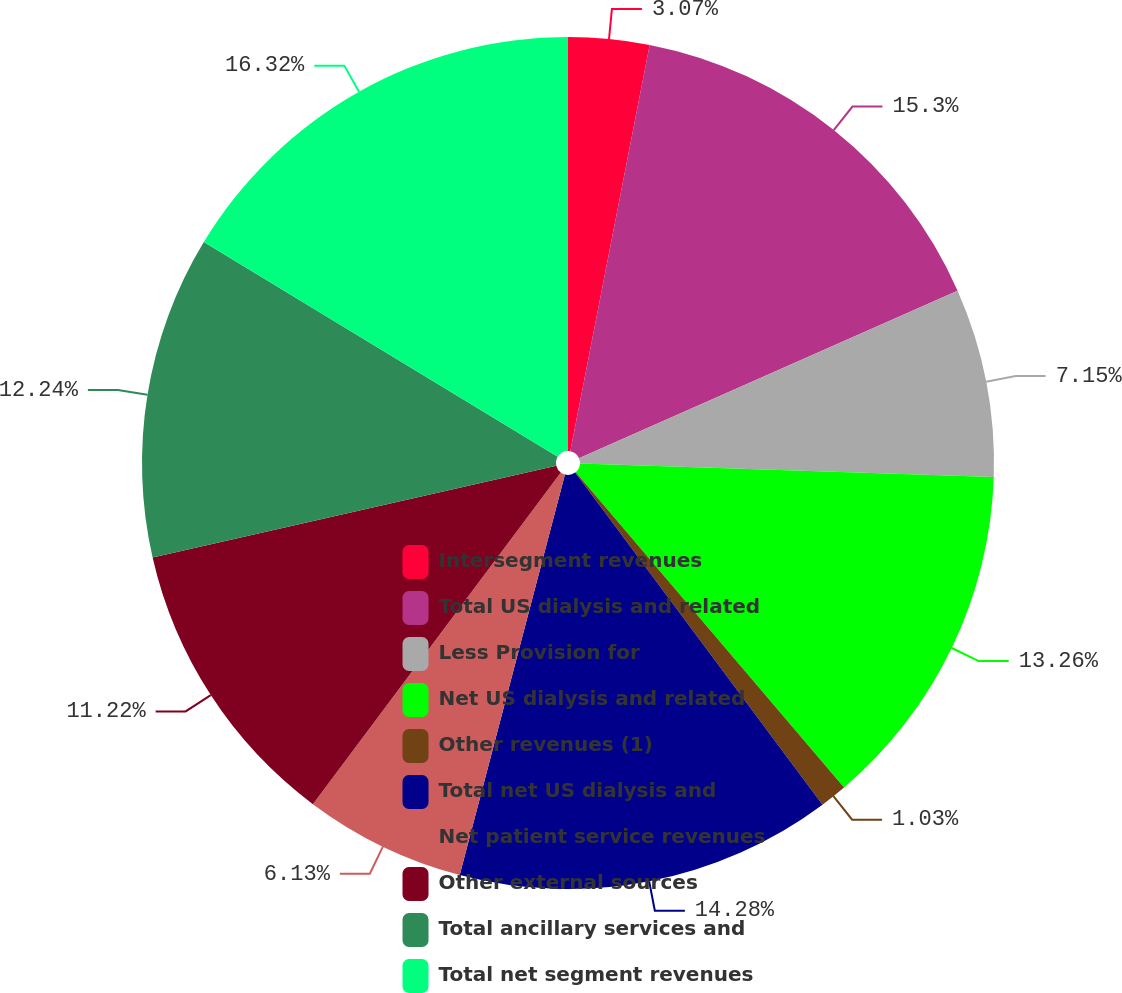Convert chart. <chart><loc_0><loc_0><loc_500><loc_500><pie_chart><fcel>Intersegment revenues<fcel>Total US dialysis and related<fcel>Less Provision for<fcel>Net US dialysis and related<fcel>Other revenues (1)<fcel>Total net US dialysis and<fcel>Net patient service revenues<fcel>Other external sources<fcel>Total ancillary services and<fcel>Total net segment revenues<nl><fcel>3.07%<fcel>15.3%<fcel>7.15%<fcel>13.26%<fcel>1.03%<fcel>14.28%<fcel>6.13%<fcel>11.22%<fcel>12.24%<fcel>16.32%<nl></chart> 